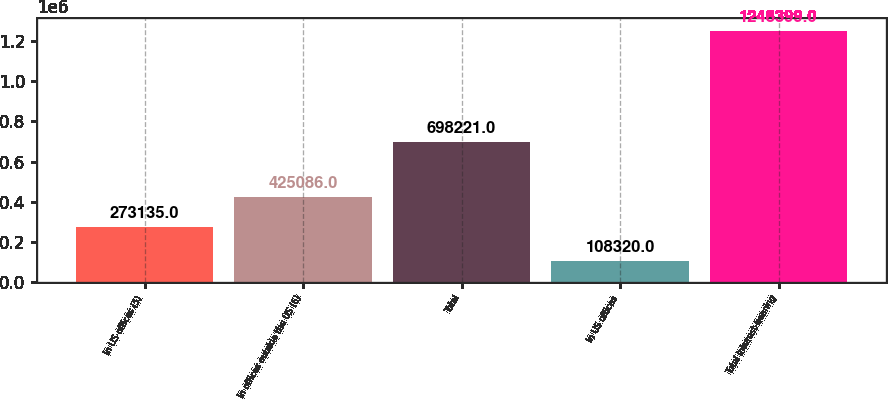Convert chart to OTSL. <chart><loc_0><loc_0><loc_500><loc_500><bar_chart><fcel>In US offices (5)<fcel>In offices outside the US (6)<fcel>Total<fcel>In US offices<fcel>Total interest-bearing<nl><fcel>273135<fcel>425086<fcel>698221<fcel>108320<fcel>1.2484e+06<nl></chart> 